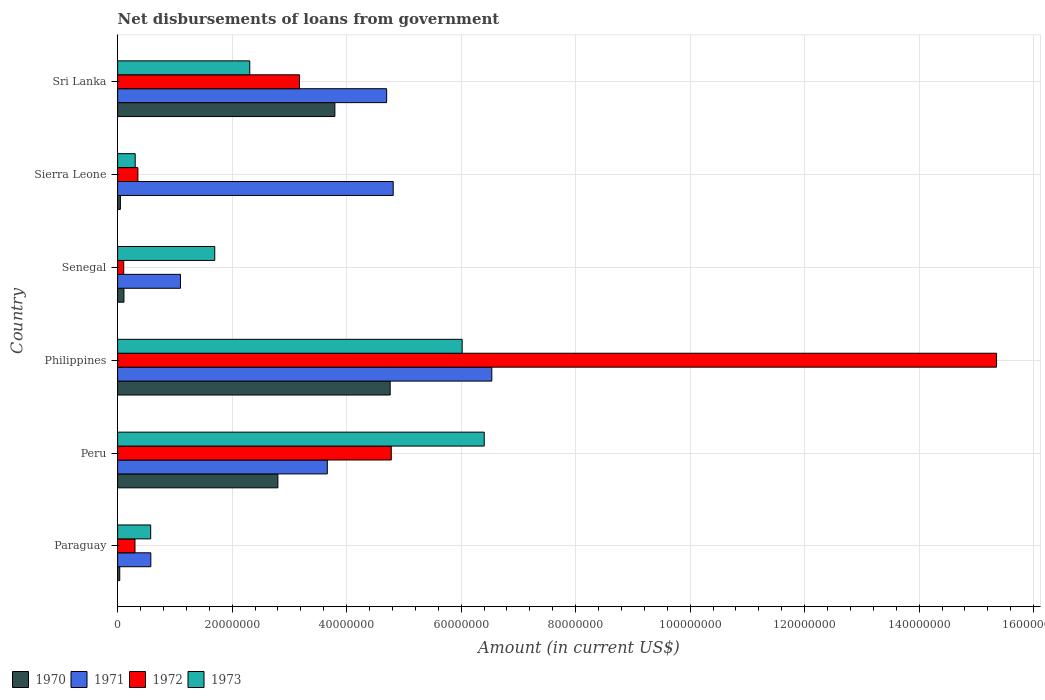How many different coloured bars are there?
Provide a short and direct response. 4. Are the number of bars per tick equal to the number of legend labels?
Your answer should be compact. Yes. Are the number of bars on each tick of the Y-axis equal?
Your response must be concise. Yes. How many bars are there on the 3rd tick from the top?
Provide a succinct answer. 4. How many bars are there on the 5th tick from the bottom?
Keep it short and to the point. 4. What is the amount of loan disbursed from government in 1972 in Paraguay?
Your answer should be compact. 3.04e+06. Across all countries, what is the maximum amount of loan disbursed from government in 1972?
Provide a short and direct response. 1.54e+08. Across all countries, what is the minimum amount of loan disbursed from government in 1971?
Offer a very short reply. 5.80e+06. In which country was the amount of loan disbursed from government in 1972 minimum?
Offer a terse response. Senegal. What is the total amount of loan disbursed from government in 1972 in the graph?
Provide a short and direct response. 2.41e+08. What is the difference between the amount of loan disbursed from government in 1973 in Peru and that in Senegal?
Make the answer very short. 4.71e+07. What is the difference between the amount of loan disbursed from government in 1970 in Philippines and the amount of loan disbursed from government in 1971 in Peru?
Give a very brief answer. 1.10e+07. What is the average amount of loan disbursed from government in 1970 per country?
Offer a terse response. 1.93e+07. What is the difference between the amount of loan disbursed from government in 1973 and amount of loan disbursed from government in 1970 in Peru?
Your answer should be compact. 3.60e+07. In how many countries, is the amount of loan disbursed from government in 1971 greater than 144000000 US$?
Your answer should be compact. 0. What is the ratio of the amount of loan disbursed from government in 1972 in Paraguay to that in Philippines?
Offer a very short reply. 0.02. Is the difference between the amount of loan disbursed from government in 1973 in Paraguay and Sierra Leone greater than the difference between the amount of loan disbursed from government in 1970 in Paraguay and Sierra Leone?
Offer a very short reply. Yes. What is the difference between the highest and the second highest amount of loan disbursed from government in 1971?
Provide a short and direct response. 1.72e+07. What is the difference between the highest and the lowest amount of loan disbursed from government in 1973?
Offer a very short reply. 6.10e+07. In how many countries, is the amount of loan disbursed from government in 1970 greater than the average amount of loan disbursed from government in 1970 taken over all countries?
Give a very brief answer. 3. Is it the case that in every country, the sum of the amount of loan disbursed from government in 1973 and amount of loan disbursed from government in 1971 is greater than the sum of amount of loan disbursed from government in 1970 and amount of loan disbursed from government in 1972?
Your answer should be very brief. Yes. Are the values on the major ticks of X-axis written in scientific E-notation?
Offer a terse response. No. Does the graph contain grids?
Offer a very short reply. Yes. How are the legend labels stacked?
Offer a very short reply. Horizontal. What is the title of the graph?
Provide a short and direct response. Net disbursements of loans from government. What is the Amount (in current US$) in 1970 in Paraguay?
Ensure brevity in your answer.  3.74e+05. What is the Amount (in current US$) in 1971 in Paraguay?
Keep it short and to the point. 5.80e+06. What is the Amount (in current US$) of 1972 in Paraguay?
Your answer should be compact. 3.04e+06. What is the Amount (in current US$) of 1973 in Paraguay?
Make the answer very short. 5.78e+06. What is the Amount (in current US$) of 1970 in Peru?
Your response must be concise. 2.80e+07. What is the Amount (in current US$) in 1971 in Peru?
Make the answer very short. 3.66e+07. What is the Amount (in current US$) of 1972 in Peru?
Your answer should be very brief. 4.78e+07. What is the Amount (in current US$) in 1973 in Peru?
Provide a succinct answer. 6.40e+07. What is the Amount (in current US$) in 1970 in Philippines?
Ensure brevity in your answer.  4.76e+07. What is the Amount (in current US$) of 1971 in Philippines?
Offer a terse response. 6.54e+07. What is the Amount (in current US$) of 1972 in Philippines?
Provide a succinct answer. 1.54e+08. What is the Amount (in current US$) of 1973 in Philippines?
Your answer should be compact. 6.02e+07. What is the Amount (in current US$) of 1970 in Senegal?
Make the answer very short. 1.11e+06. What is the Amount (in current US$) of 1971 in Senegal?
Your answer should be compact. 1.10e+07. What is the Amount (in current US$) of 1972 in Senegal?
Your answer should be compact. 1.07e+06. What is the Amount (in current US$) in 1973 in Senegal?
Offer a very short reply. 1.70e+07. What is the Amount (in current US$) in 1970 in Sierra Leone?
Offer a terse response. 4.87e+05. What is the Amount (in current US$) of 1971 in Sierra Leone?
Ensure brevity in your answer.  4.81e+07. What is the Amount (in current US$) of 1972 in Sierra Leone?
Your answer should be very brief. 3.54e+06. What is the Amount (in current US$) of 1973 in Sierra Leone?
Make the answer very short. 3.07e+06. What is the Amount (in current US$) in 1970 in Sri Lanka?
Provide a short and direct response. 3.79e+07. What is the Amount (in current US$) in 1971 in Sri Lanka?
Give a very brief answer. 4.70e+07. What is the Amount (in current US$) of 1972 in Sri Lanka?
Your answer should be very brief. 3.18e+07. What is the Amount (in current US$) in 1973 in Sri Lanka?
Your answer should be very brief. 2.31e+07. Across all countries, what is the maximum Amount (in current US$) in 1970?
Make the answer very short. 4.76e+07. Across all countries, what is the maximum Amount (in current US$) of 1971?
Offer a terse response. 6.54e+07. Across all countries, what is the maximum Amount (in current US$) of 1972?
Offer a terse response. 1.54e+08. Across all countries, what is the maximum Amount (in current US$) of 1973?
Ensure brevity in your answer.  6.40e+07. Across all countries, what is the minimum Amount (in current US$) of 1970?
Provide a short and direct response. 3.74e+05. Across all countries, what is the minimum Amount (in current US$) in 1971?
Your response must be concise. 5.80e+06. Across all countries, what is the minimum Amount (in current US$) of 1972?
Your response must be concise. 1.07e+06. Across all countries, what is the minimum Amount (in current US$) in 1973?
Offer a very short reply. 3.07e+06. What is the total Amount (in current US$) in 1970 in the graph?
Offer a terse response. 1.16e+08. What is the total Amount (in current US$) of 1971 in the graph?
Give a very brief answer. 2.14e+08. What is the total Amount (in current US$) in 1972 in the graph?
Your answer should be very brief. 2.41e+08. What is the total Amount (in current US$) in 1973 in the graph?
Offer a terse response. 1.73e+08. What is the difference between the Amount (in current US$) in 1970 in Paraguay and that in Peru?
Offer a very short reply. -2.76e+07. What is the difference between the Amount (in current US$) in 1971 in Paraguay and that in Peru?
Give a very brief answer. -3.08e+07. What is the difference between the Amount (in current US$) of 1972 in Paraguay and that in Peru?
Offer a terse response. -4.48e+07. What is the difference between the Amount (in current US$) of 1973 in Paraguay and that in Peru?
Your answer should be compact. -5.83e+07. What is the difference between the Amount (in current US$) of 1970 in Paraguay and that in Philippines?
Give a very brief answer. -4.72e+07. What is the difference between the Amount (in current US$) in 1971 in Paraguay and that in Philippines?
Offer a very short reply. -5.96e+07. What is the difference between the Amount (in current US$) in 1972 in Paraguay and that in Philippines?
Provide a succinct answer. -1.50e+08. What is the difference between the Amount (in current US$) of 1973 in Paraguay and that in Philippines?
Your response must be concise. -5.44e+07. What is the difference between the Amount (in current US$) in 1970 in Paraguay and that in Senegal?
Your answer should be compact. -7.32e+05. What is the difference between the Amount (in current US$) of 1971 in Paraguay and that in Senegal?
Your response must be concise. -5.18e+06. What is the difference between the Amount (in current US$) of 1972 in Paraguay and that in Senegal?
Provide a succinct answer. 1.97e+06. What is the difference between the Amount (in current US$) of 1973 in Paraguay and that in Senegal?
Provide a short and direct response. -1.12e+07. What is the difference between the Amount (in current US$) in 1970 in Paraguay and that in Sierra Leone?
Your answer should be very brief. -1.13e+05. What is the difference between the Amount (in current US$) of 1971 in Paraguay and that in Sierra Leone?
Ensure brevity in your answer.  -4.23e+07. What is the difference between the Amount (in current US$) in 1972 in Paraguay and that in Sierra Leone?
Provide a short and direct response. -5.07e+05. What is the difference between the Amount (in current US$) in 1973 in Paraguay and that in Sierra Leone?
Ensure brevity in your answer.  2.70e+06. What is the difference between the Amount (in current US$) of 1970 in Paraguay and that in Sri Lanka?
Offer a terse response. -3.76e+07. What is the difference between the Amount (in current US$) of 1971 in Paraguay and that in Sri Lanka?
Provide a short and direct response. -4.12e+07. What is the difference between the Amount (in current US$) in 1972 in Paraguay and that in Sri Lanka?
Provide a succinct answer. -2.87e+07. What is the difference between the Amount (in current US$) in 1973 in Paraguay and that in Sri Lanka?
Offer a very short reply. -1.73e+07. What is the difference between the Amount (in current US$) in 1970 in Peru and that in Philippines?
Offer a very short reply. -1.96e+07. What is the difference between the Amount (in current US$) in 1971 in Peru and that in Philippines?
Give a very brief answer. -2.87e+07. What is the difference between the Amount (in current US$) in 1972 in Peru and that in Philippines?
Provide a succinct answer. -1.06e+08. What is the difference between the Amount (in current US$) of 1973 in Peru and that in Philippines?
Provide a short and direct response. 3.86e+06. What is the difference between the Amount (in current US$) of 1970 in Peru and that in Senegal?
Your answer should be compact. 2.69e+07. What is the difference between the Amount (in current US$) of 1971 in Peru and that in Senegal?
Keep it short and to the point. 2.56e+07. What is the difference between the Amount (in current US$) in 1972 in Peru and that in Senegal?
Provide a succinct answer. 4.67e+07. What is the difference between the Amount (in current US$) of 1973 in Peru and that in Senegal?
Your answer should be compact. 4.71e+07. What is the difference between the Amount (in current US$) in 1970 in Peru and that in Sierra Leone?
Give a very brief answer. 2.75e+07. What is the difference between the Amount (in current US$) in 1971 in Peru and that in Sierra Leone?
Your answer should be very brief. -1.15e+07. What is the difference between the Amount (in current US$) of 1972 in Peru and that in Sierra Leone?
Your response must be concise. 4.43e+07. What is the difference between the Amount (in current US$) of 1973 in Peru and that in Sierra Leone?
Provide a short and direct response. 6.10e+07. What is the difference between the Amount (in current US$) of 1970 in Peru and that in Sri Lanka?
Your answer should be very brief. -9.95e+06. What is the difference between the Amount (in current US$) in 1971 in Peru and that in Sri Lanka?
Your answer should be compact. -1.04e+07. What is the difference between the Amount (in current US$) of 1972 in Peru and that in Sri Lanka?
Provide a succinct answer. 1.60e+07. What is the difference between the Amount (in current US$) in 1973 in Peru and that in Sri Lanka?
Provide a succinct answer. 4.10e+07. What is the difference between the Amount (in current US$) in 1970 in Philippines and that in Senegal?
Your response must be concise. 4.65e+07. What is the difference between the Amount (in current US$) of 1971 in Philippines and that in Senegal?
Offer a very short reply. 5.44e+07. What is the difference between the Amount (in current US$) in 1972 in Philippines and that in Senegal?
Your answer should be compact. 1.52e+08. What is the difference between the Amount (in current US$) in 1973 in Philippines and that in Senegal?
Your answer should be compact. 4.32e+07. What is the difference between the Amount (in current US$) in 1970 in Philippines and that in Sierra Leone?
Offer a very short reply. 4.71e+07. What is the difference between the Amount (in current US$) in 1971 in Philippines and that in Sierra Leone?
Offer a terse response. 1.72e+07. What is the difference between the Amount (in current US$) of 1972 in Philippines and that in Sierra Leone?
Provide a succinct answer. 1.50e+08. What is the difference between the Amount (in current US$) in 1973 in Philippines and that in Sierra Leone?
Provide a short and direct response. 5.71e+07. What is the difference between the Amount (in current US$) of 1970 in Philippines and that in Sri Lanka?
Make the answer very short. 9.66e+06. What is the difference between the Amount (in current US$) of 1971 in Philippines and that in Sri Lanka?
Provide a short and direct response. 1.84e+07. What is the difference between the Amount (in current US$) of 1972 in Philippines and that in Sri Lanka?
Offer a terse response. 1.22e+08. What is the difference between the Amount (in current US$) of 1973 in Philippines and that in Sri Lanka?
Offer a terse response. 3.71e+07. What is the difference between the Amount (in current US$) of 1970 in Senegal and that in Sierra Leone?
Your answer should be compact. 6.19e+05. What is the difference between the Amount (in current US$) of 1971 in Senegal and that in Sierra Leone?
Make the answer very short. -3.72e+07. What is the difference between the Amount (in current US$) of 1972 in Senegal and that in Sierra Leone?
Ensure brevity in your answer.  -2.48e+06. What is the difference between the Amount (in current US$) in 1973 in Senegal and that in Sierra Leone?
Your answer should be compact. 1.39e+07. What is the difference between the Amount (in current US$) of 1970 in Senegal and that in Sri Lanka?
Make the answer very short. -3.68e+07. What is the difference between the Amount (in current US$) in 1971 in Senegal and that in Sri Lanka?
Offer a very short reply. -3.60e+07. What is the difference between the Amount (in current US$) in 1972 in Senegal and that in Sri Lanka?
Your response must be concise. -3.07e+07. What is the difference between the Amount (in current US$) of 1973 in Senegal and that in Sri Lanka?
Provide a short and direct response. -6.12e+06. What is the difference between the Amount (in current US$) in 1970 in Sierra Leone and that in Sri Lanka?
Provide a succinct answer. -3.75e+07. What is the difference between the Amount (in current US$) of 1971 in Sierra Leone and that in Sri Lanka?
Offer a very short reply. 1.15e+06. What is the difference between the Amount (in current US$) of 1972 in Sierra Leone and that in Sri Lanka?
Give a very brief answer. -2.82e+07. What is the difference between the Amount (in current US$) in 1973 in Sierra Leone and that in Sri Lanka?
Provide a short and direct response. -2.00e+07. What is the difference between the Amount (in current US$) of 1970 in Paraguay and the Amount (in current US$) of 1971 in Peru?
Offer a terse response. -3.63e+07. What is the difference between the Amount (in current US$) of 1970 in Paraguay and the Amount (in current US$) of 1972 in Peru?
Keep it short and to the point. -4.74e+07. What is the difference between the Amount (in current US$) of 1970 in Paraguay and the Amount (in current US$) of 1973 in Peru?
Provide a short and direct response. -6.37e+07. What is the difference between the Amount (in current US$) in 1971 in Paraguay and the Amount (in current US$) in 1972 in Peru?
Your response must be concise. -4.20e+07. What is the difference between the Amount (in current US$) in 1971 in Paraguay and the Amount (in current US$) in 1973 in Peru?
Your answer should be very brief. -5.82e+07. What is the difference between the Amount (in current US$) in 1972 in Paraguay and the Amount (in current US$) in 1973 in Peru?
Your response must be concise. -6.10e+07. What is the difference between the Amount (in current US$) of 1970 in Paraguay and the Amount (in current US$) of 1971 in Philippines?
Your answer should be compact. -6.50e+07. What is the difference between the Amount (in current US$) in 1970 in Paraguay and the Amount (in current US$) in 1972 in Philippines?
Keep it short and to the point. -1.53e+08. What is the difference between the Amount (in current US$) in 1970 in Paraguay and the Amount (in current US$) in 1973 in Philippines?
Provide a succinct answer. -5.98e+07. What is the difference between the Amount (in current US$) in 1971 in Paraguay and the Amount (in current US$) in 1972 in Philippines?
Offer a terse response. -1.48e+08. What is the difference between the Amount (in current US$) in 1971 in Paraguay and the Amount (in current US$) in 1973 in Philippines?
Keep it short and to the point. -5.44e+07. What is the difference between the Amount (in current US$) in 1972 in Paraguay and the Amount (in current US$) in 1973 in Philippines?
Your answer should be compact. -5.71e+07. What is the difference between the Amount (in current US$) in 1970 in Paraguay and the Amount (in current US$) in 1971 in Senegal?
Give a very brief answer. -1.06e+07. What is the difference between the Amount (in current US$) in 1970 in Paraguay and the Amount (in current US$) in 1972 in Senegal?
Offer a terse response. -6.92e+05. What is the difference between the Amount (in current US$) in 1970 in Paraguay and the Amount (in current US$) in 1973 in Senegal?
Keep it short and to the point. -1.66e+07. What is the difference between the Amount (in current US$) in 1971 in Paraguay and the Amount (in current US$) in 1972 in Senegal?
Offer a very short reply. 4.74e+06. What is the difference between the Amount (in current US$) in 1971 in Paraguay and the Amount (in current US$) in 1973 in Senegal?
Give a very brief answer. -1.12e+07. What is the difference between the Amount (in current US$) in 1972 in Paraguay and the Amount (in current US$) in 1973 in Senegal?
Offer a terse response. -1.39e+07. What is the difference between the Amount (in current US$) in 1970 in Paraguay and the Amount (in current US$) in 1971 in Sierra Leone?
Provide a short and direct response. -4.78e+07. What is the difference between the Amount (in current US$) in 1970 in Paraguay and the Amount (in current US$) in 1972 in Sierra Leone?
Provide a short and direct response. -3.17e+06. What is the difference between the Amount (in current US$) in 1970 in Paraguay and the Amount (in current US$) in 1973 in Sierra Leone?
Keep it short and to the point. -2.70e+06. What is the difference between the Amount (in current US$) in 1971 in Paraguay and the Amount (in current US$) in 1972 in Sierra Leone?
Provide a short and direct response. 2.26e+06. What is the difference between the Amount (in current US$) in 1971 in Paraguay and the Amount (in current US$) in 1973 in Sierra Leone?
Keep it short and to the point. 2.73e+06. What is the difference between the Amount (in current US$) of 1972 in Paraguay and the Amount (in current US$) of 1973 in Sierra Leone?
Your response must be concise. -3.80e+04. What is the difference between the Amount (in current US$) in 1970 in Paraguay and the Amount (in current US$) in 1971 in Sri Lanka?
Your answer should be compact. -4.66e+07. What is the difference between the Amount (in current US$) of 1970 in Paraguay and the Amount (in current US$) of 1972 in Sri Lanka?
Offer a terse response. -3.14e+07. What is the difference between the Amount (in current US$) of 1970 in Paraguay and the Amount (in current US$) of 1973 in Sri Lanka?
Provide a short and direct response. -2.27e+07. What is the difference between the Amount (in current US$) of 1971 in Paraguay and the Amount (in current US$) of 1972 in Sri Lanka?
Keep it short and to the point. -2.60e+07. What is the difference between the Amount (in current US$) in 1971 in Paraguay and the Amount (in current US$) in 1973 in Sri Lanka?
Make the answer very short. -1.73e+07. What is the difference between the Amount (in current US$) in 1972 in Paraguay and the Amount (in current US$) in 1973 in Sri Lanka?
Ensure brevity in your answer.  -2.00e+07. What is the difference between the Amount (in current US$) of 1970 in Peru and the Amount (in current US$) of 1971 in Philippines?
Your answer should be compact. -3.74e+07. What is the difference between the Amount (in current US$) of 1970 in Peru and the Amount (in current US$) of 1972 in Philippines?
Offer a very short reply. -1.26e+08. What is the difference between the Amount (in current US$) of 1970 in Peru and the Amount (in current US$) of 1973 in Philippines?
Your response must be concise. -3.22e+07. What is the difference between the Amount (in current US$) in 1971 in Peru and the Amount (in current US$) in 1972 in Philippines?
Ensure brevity in your answer.  -1.17e+08. What is the difference between the Amount (in current US$) in 1971 in Peru and the Amount (in current US$) in 1973 in Philippines?
Your answer should be compact. -2.36e+07. What is the difference between the Amount (in current US$) of 1972 in Peru and the Amount (in current US$) of 1973 in Philippines?
Make the answer very short. -1.24e+07. What is the difference between the Amount (in current US$) in 1970 in Peru and the Amount (in current US$) in 1971 in Senegal?
Keep it short and to the point. 1.70e+07. What is the difference between the Amount (in current US$) of 1970 in Peru and the Amount (in current US$) of 1972 in Senegal?
Offer a very short reply. 2.69e+07. What is the difference between the Amount (in current US$) of 1970 in Peru and the Amount (in current US$) of 1973 in Senegal?
Make the answer very short. 1.10e+07. What is the difference between the Amount (in current US$) of 1971 in Peru and the Amount (in current US$) of 1972 in Senegal?
Keep it short and to the point. 3.56e+07. What is the difference between the Amount (in current US$) of 1971 in Peru and the Amount (in current US$) of 1973 in Senegal?
Provide a succinct answer. 1.97e+07. What is the difference between the Amount (in current US$) in 1972 in Peru and the Amount (in current US$) in 1973 in Senegal?
Give a very brief answer. 3.08e+07. What is the difference between the Amount (in current US$) of 1970 in Peru and the Amount (in current US$) of 1971 in Sierra Leone?
Provide a succinct answer. -2.01e+07. What is the difference between the Amount (in current US$) of 1970 in Peru and the Amount (in current US$) of 1972 in Sierra Leone?
Provide a succinct answer. 2.45e+07. What is the difference between the Amount (in current US$) of 1970 in Peru and the Amount (in current US$) of 1973 in Sierra Leone?
Offer a terse response. 2.49e+07. What is the difference between the Amount (in current US$) in 1971 in Peru and the Amount (in current US$) in 1972 in Sierra Leone?
Your response must be concise. 3.31e+07. What is the difference between the Amount (in current US$) of 1971 in Peru and the Amount (in current US$) of 1973 in Sierra Leone?
Make the answer very short. 3.36e+07. What is the difference between the Amount (in current US$) of 1972 in Peru and the Amount (in current US$) of 1973 in Sierra Leone?
Give a very brief answer. 4.47e+07. What is the difference between the Amount (in current US$) of 1970 in Peru and the Amount (in current US$) of 1971 in Sri Lanka?
Ensure brevity in your answer.  -1.90e+07. What is the difference between the Amount (in current US$) in 1970 in Peru and the Amount (in current US$) in 1972 in Sri Lanka?
Provide a short and direct response. -3.77e+06. What is the difference between the Amount (in current US$) of 1970 in Peru and the Amount (in current US$) of 1973 in Sri Lanka?
Keep it short and to the point. 4.91e+06. What is the difference between the Amount (in current US$) in 1971 in Peru and the Amount (in current US$) in 1972 in Sri Lanka?
Offer a very short reply. 4.86e+06. What is the difference between the Amount (in current US$) in 1971 in Peru and the Amount (in current US$) in 1973 in Sri Lanka?
Your response must be concise. 1.35e+07. What is the difference between the Amount (in current US$) of 1972 in Peru and the Amount (in current US$) of 1973 in Sri Lanka?
Provide a succinct answer. 2.47e+07. What is the difference between the Amount (in current US$) of 1970 in Philippines and the Amount (in current US$) of 1971 in Senegal?
Your answer should be very brief. 3.66e+07. What is the difference between the Amount (in current US$) of 1970 in Philippines and the Amount (in current US$) of 1972 in Senegal?
Ensure brevity in your answer.  4.65e+07. What is the difference between the Amount (in current US$) of 1970 in Philippines and the Amount (in current US$) of 1973 in Senegal?
Make the answer very short. 3.06e+07. What is the difference between the Amount (in current US$) in 1971 in Philippines and the Amount (in current US$) in 1972 in Senegal?
Ensure brevity in your answer.  6.43e+07. What is the difference between the Amount (in current US$) of 1971 in Philippines and the Amount (in current US$) of 1973 in Senegal?
Provide a succinct answer. 4.84e+07. What is the difference between the Amount (in current US$) of 1972 in Philippines and the Amount (in current US$) of 1973 in Senegal?
Offer a terse response. 1.37e+08. What is the difference between the Amount (in current US$) in 1970 in Philippines and the Amount (in current US$) in 1971 in Sierra Leone?
Your response must be concise. -5.32e+05. What is the difference between the Amount (in current US$) of 1970 in Philippines and the Amount (in current US$) of 1972 in Sierra Leone?
Make the answer very short. 4.41e+07. What is the difference between the Amount (in current US$) of 1970 in Philippines and the Amount (in current US$) of 1973 in Sierra Leone?
Your answer should be very brief. 4.45e+07. What is the difference between the Amount (in current US$) in 1971 in Philippines and the Amount (in current US$) in 1972 in Sierra Leone?
Keep it short and to the point. 6.18e+07. What is the difference between the Amount (in current US$) in 1971 in Philippines and the Amount (in current US$) in 1973 in Sierra Leone?
Provide a short and direct response. 6.23e+07. What is the difference between the Amount (in current US$) of 1972 in Philippines and the Amount (in current US$) of 1973 in Sierra Leone?
Your answer should be compact. 1.50e+08. What is the difference between the Amount (in current US$) of 1970 in Philippines and the Amount (in current US$) of 1971 in Sri Lanka?
Make the answer very short. 6.15e+05. What is the difference between the Amount (in current US$) in 1970 in Philippines and the Amount (in current US$) in 1972 in Sri Lanka?
Ensure brevity in your answer.  1.58e+07. What is the difference between the Amount (in current US$) of 1970 in Philippines and the Amount (in current US$) of 1973 in Sri Lanka?
Give a very brief answer. 2.45e+07. What is the difference between the Amount (in current US$) of 1971 in Philippines and the Amount (in current US$) of 1972 in Sri Lanka?
Give a very brief answer. 3.36e+07. What is the difference between the Amount (in current US$) in 1971 in Philippines and the Amount (in current US$) in 1973 in Sri Lanka?
Provide a short and direct response. 4.23e+07. What is the difference between the Amount (in current US$) of 1972 in Philippines and the Amount (in current US$) of 1973 in Sri Lanka?
Provide a short and direct response. 1.30e+08. What is the difference between the Amount (in current US$) of 1970 in Senegal and the Amount (in current US$) of 1971 in Sierra Leone?
Provide a short and direct response. -4.70e+07. What is the difference between the Amount (in current US$) of 1970 in Senegal and the Amount (in current US$) of 1972 in Sierra Leone?
Your response must be concise. -2.44e+06. What is the difference between the Amount (in current US$) in 1970 in Senegal and the Amount (in current US$) in 1973 in Sierra Leone?
Keep it short and to the point. -1.97e+06. What is the difference between the Amount (in current US$) of 1971 in Senegal and the Amount (in current US$) of 1972 in Sierra Leone?
Provide a short and direct response. 7.44e+06. What is the difference between the Amount (in current US$) of 1971 in Senegal and the Amount (in current US$) of 1973 in Sierra Leone?
Offer a very short reply. 7.90e+06. What is the difference between the Amount (in current US$) in 1972 in Senegal and the Amount (in current US$) in 1973 in Sierra Leone?
Your answer should be very brief. -2.01e+06. What is the difference between the Amount (in current US$) in 1970 in Senegal and the Amount (in current US$) in 1971 in Sri Lanka?
Make the answer very short. -4.59e+07. What is the difference between the Amount (in current US$) in 1970 in Senegal and the Amount (in current US$) in 1972 in Sri Lanka?
Offer a terse response. -3.07e+07. What is the difference between the Amount (in current US$) of 1970 in Senegal and the Amount (in current US$) of 1973 in Sri Lanka?
Offer a terse response. -2.20e+07. What is the difference between the Amount (in current US$) in 1971 in Senegal and the Amount (in current US$) in 1972 in Sri Lanka?
Give a very brief answer. -2.08e+07. What is the difference between the Amount (in current US$) in 1971 in Senegal and the Amount (in current US$) in 1973 in Sri Lanka?
Provide a succinct answer. -1.21e+07. What is the difference between the Amount (in current US$) of 1972 in Senegal and the Amount (in current US$) of 1973 in Sri Lanka?
Give a very brief answer. -2.20e+07. What is the difference between the Amount (in current US$) of 1970 in Sierra Leone and the Amount (in current US$) of 1971 in Sri Lanka?
Your answer should be compact. -4.65e+07. What is the difference between the Amount (in current US$) of 1970 in Sierra Leone and the Amount (in current US$) of 1972 in Sri Lanka?
Offer a very short reply. -3.13e+07. What is the difference between the Amount (in current US$) of 1970 in Sierra Leone and the Amount (in current US$) of 1973 in Sri Lanka?
Offer a terse response. -2.26e+07. What is the difference between the Amount (in current US$) of 1971 in Sierra Leone and the Amount (in current US$) of 1972 in Sri Lanka?
Give a very brief answer. 1.64e+07. What is the difference between the Amount (in current US$) in 1971 in Sierra Leone and the Amount (in current US$) in 1973 in Sri Lanka?
Ensure brevity in your answer.  2.51e+07. What is the difference between the Amount (in current US$) in 1972 in Sierra Leone and the Amount (in current US$) in 1973 in Sri Lanka?
Your response must be concise. -1.95e+07. What is the average Amount (in current US$) of 1970 per country?
Offer a very short reply. 1.93e+07. What is the average Amount (in current US$) in 1971 per country?
Keep it short and to the point. 3.56e+07. What is the average Amount (in current US$) of 1972 per country?
Provide a succinct answer. 4.01e+07. What is the average Amount (in current US$) of 1973 per country?
Provide a short and direct response. 2.89e+07. What is the difference between the Amount (in current US$) of 1970 and Amount (in current US$) of 1971 in Paraguay?
Your response must be concise. -5.43e+06. What is the difference between the Amount (in current US$) of 1970 and Amount (in current US$) of 1972 in Paraguay?
Keep it short and to the point. -2.66e+06. What is the difference between the Amount (in current US$) in 1970 and Amount (in current US$) in 1973 in Paraguay?
Your response must be concise. -5.40e+06. What is the difference between the Amount (in current US$) of 1971 and Amount (in current US$) of 1972 in Paraguay?
Keep it short and to the point. 2.77e+06. What is the difference between the Amount (in current US$) in 1971 and Amount (in current US$) in 1973 in Paraguay?
Provide a short and direct response. 2.50e+04. What is the difference between the Amount (in current US$) of 1972 and Amount (in current US$) of 1973 in Paraguay?
Offer a very short reply. -2.74e+06. What is the difference between the Amount (in current US$) of 1970 and Amount (in current US$) of 1971 in Peru?
Provide a short and direct response. -8.63e+06. What is the difference between the Amount (in current US$) in 1970 and Amount (in current US$) in 1972 in Peru?
Ensure brevity in your answer.  -1.98e+07. What is the difference between the Amount (in current US$) of 1970 and Amount (in current US$) of 1973 in Peru?
Your response must be concise. -3.60e+07. What is the difference between the Amount (in current US$) in 1971 and Amount (in current US$) in 1972 in Peru?
Your answer should be compact. -1.12e+07. What is the difference between the Amount (in current US$) in 1971 and Amount (in current US$) in 1973 in Peru?
Provide a short and direct response. -2.74e+07. What is the difference between the Amount (in current US$) in 1972 and Amount (in current US$) in 1973 in Peru?
Offer a very short reply. -1.62e+07. What is the difference between the Amount (in current US$) in 1970 and Amount (in current US$) in 1971 in Philippines?
Your answer should be very brief. -1.78e+07. What is the difference between the Amount (in current US$) of 1970 and Amount (in current US$) of 1972 in Philippines?
Your answer should be very brief. -1.06e+08. What is the difference between the Amount (in current US$) of 1970 and Amount (in current US$) of 1973 in Philippines?
Give a very brief answer. -1.26e+07. What is the difference between the Amount (in current US$) of 1971 and Amount (in current US$) of 1972 in Philippines?
Provide a succinct answer. -8.82e+07. What is the difference between the Amount (in current US$) in 1971 and Amount (in current US$) in 1973 in Philippines?
Offer a very short reply. 5.18e+06. What is the difference between the Amount (in current US$) of 1972 and Amount (in current US$) of 1973 in Philippines?
Give a very brief answer. 9.33e+07. What is the difference between the Amount (in current US$) of 1970 and Amount (in current US$) of 1971 in Senegal?
Offer a terse response. -9.87e+06. What is the difference between the Amount (in current US$) of 1970 and Amount (in current US$) of 1972 in Senegal?
Give a very brief answer. 4.00e+04. What is the difference between the Amount (in current US$) of 1970 and Amount (in current US$) of 1973 in Senegal?
Your response must be concise. -1.59e+07. What is the difference between the Amount (in current US$) in 1971 and Amount (in current US$) in 1972 in Senegal?
Make the answer very short. 9.91e+06. What is the difference between the Amount (in current US$) in 1971 and Amount (in current US$) in 1973 in Senegal?
Your answer should be compact. -5.99e+06. What is the difference between the Amount (in current US$) of 1972 and Amount (in current US$) of 1973 in Senegal?
Offer a very short reply. -1.59e+07. What is the difference between the Amount (in current US$) in 1970 and Amount (in current US$) in 1971 in Sierra Leone?
Provide a short and direct response. -4.77e+07. What is the difference between the Amount (in current US$) of 1970 and Amount (in current US$) of 1972 in Sierra Leone?
Offer a very short reply. -3.06e+06. What is the difference between the Amount (in current US$) of 1970 and Amount (in current US$) of 1973 in Sierra Leone?
Provide a short and direct response. -2.59e+06. What is the difference between the Amount (in current US$) of 1971 and Amount (in current US$) of 1972 in Sierra Leone?
Provide a short and direct response. 4.46e+07. What is the difference between the Amount (in current US$) of 1971 and Amount (in current US$) of 1973 in Sierra Leone?
Provide a succinct answer. 4.51e+07. What is the difference between the Amount (in current US$) in 1972 and Amount (in current US$) in 1973 in Sierra Leone?
Provide a short and direct response. 4.69e+05. What is the difference between the Amount (in current US$) of 1970 and Amount (in current US$) of 1971 in Sri Lanka?
Your answer should be compact. -9.04e+06. What is the difference between the Amount (in current US$) in 1970 and Amount (in current US$) in 1972 in Sri Lanka?
Keep it short and to the point. 6.18e+06. What is the difference between the Amount (in current US$) in 1970 and Amount (in current US$) in 1973 in Sri Lanka?
Provide a succinct answer. 1.49e+07. What is the difference between the Amount (in current US$) in 1971 and Amount (in current US$) in 1972 in Sri Lanka?
Your answer should be very brief. 1.52e+07. What is the difference between the Amount (in current US$) of 1971 and Amount (in current US$) of 1973 in Sri Lanka?
Your answer should be compact. 2.39e+07. What is the difference between the Amount (in current US$) in 1972 and Amount (in current US$) in 1973 in Sri Lanka?
Provide a succinct answer. 8.69e+06. What is the ratio of the Amount (in current US$) of 1970 in Paraguay to that in Peru?
Provide a succinct answer. 0.01. What is the ratio of the Amount (in current US$) in 1971 in Paraguay to that in Peru?
Make the answer very short. 0.16. What is the ratio of the Amount (in current US$) of 1972 in Paraguay to that in Peru?
Your response must be concise. 0.06. What is the ratio of the Amount (in current US$) in 1973 in Paraguay to that in Peru?
Make the answer very short. 0.09. What is the ratio of the Amount (in current US$) of 1970 in Paraguay to that in Philippines?
Provide a succinct answer. 0.01. What is the ratio of the Amount (in current US$) of 1971 in Paraguay to that in Philippines?
Your answer should be very brief. 0.09. What is the ratio of the Amount (in current US$) in 1972 in Paraguay to that in Philippines?
Give a very brief answer. 0.02. What is the ratio of the Amount (in current US$) in 1973 in Paraguay to that in Philippines?
Your answer should be compact. 0.1. What is the ratio of the Amount (in current US$) in 1970 in Paraguay to that in Senegal?
Offer a very short reply. 0.34. What is the ratio of the Amount (in current US$) in 1971 in Paraguay to that in Senegal?
Offer a terse response. 0.53. What is the ratio of the Amount (in current US$) in 1972 in Paraguay to that in Senegal?
Offer a very short reply. 2.85. What is the ratio of the Amount (in current US$) in 1973 in Paraguay to that in Senegal?
Provide a short and direct response. 0.34. What is the ratio of the Amount (in current US$) of 1970 in Paraguay to that in Sierra Leone?
Ensure brevity in your answer.  0.77. What is the ratio of the Amount (in current US$) of 1971 in Paraguay to that in Sierra Leone?
Your answer should be very brief. 0.12. What is the ratio of the Amount (in current US$) in 1972 in Paraguay to that in Sierra Leone?
Give a very brief answer. 0.86. What is the ratio of the Amount (in current US$) in 1973 in Paraguay to that in Sierra Leone?
Offer a terse response. 1.88. What is the ratio of the Amount (in current US$) of 1970 in Paraguay to that in Sri Lanka?
Offer a very short reply. 0.01. What is the ratio of the Amount (in current US$) in 1971 in Paraguay to that in Sri Lanka?
Your response must be concise. 0.12. What is the ratio of the Amount (in current US$) of 1972 in Paraguay to that in Sri Lanka?
Make the answer very short. 0.1. What is the ratio of the Amount (in current US$) in 1973 in Paraguay to that in Sri Lanka?
Make the answer very short. 0.25. What is the ratio of the Amount (in current US$) in 1970 in Peru to that in Philippines?
Your answer should be compact. 0.59. What is the ratio of the Amount (in current US$) in 1971 in Peru to that in Philippines?
Offer a very short reply. 0.56. What is the ratio of the Amount (in current US$) in 1972 in Peru to that in Philippines?
Your answer should be compact. 0.31. What is the ratio of the Amount (in current US$) in 1973 in Peru to that in Philippines?
Offer a very short reply. 1.06. What is the ratio of the Amount (in current US$) of 1970 in Peru to that in Senegal?
Your answer should be very brief. 25.31. What is the ratio of the Amount (in current US$) of 1971 in Peru to that in Senegal?
Make the answer very short. 3.34. What is the ratio of the Amount (in current US$) of 1972 in Peru to that in Senegal?
Your response must be concise. 44.84. What is the ratio of the Amount (in current US$) of 1973 in Peru to that in Senegal?
Provide a succinct answer. 3.77. What is the ratio of the Amount (in current US$) in 1970 in Peru to that in Sierra Leone?
Make the answer very short. 57.49. What is the ratio of the Amount (in current US$) of 1971 in Peru to that in Sierra Leone?
Give a very brief answer. 0.76. What is the ratio of the Amount (in current US$) in 1972 in Peru to that in Sierra Leone?
Provide a short and direct response. 13.49. What is the ratio of the Amount (in current US$) in 1973 in Peru to that in Sierra Leone?
Your answer should be compact. 20.83. What is the ratio of the Amount (in current US$) of 1970 in Peru to that in Sri Lanka?
Your answer should be very brief. 0.74. What is the ratio of the Amount (in current US$) of 1971 in Peru to that in Sri Lanka?
Your answer should be compact. 0.78. What is the ratio of the Amount (in current US$) in 1972 in Peru to that in Sri Lanka?
Your response must be concise. 1.5. What is the ratio of the Amount (in current US$) in 1973 in Peru to that in Sri Lanka?
Your answer should be very brief. 2.77. What is the ratio of the Amount (in current US$) in 1970 in Philippines to that in Senegal?
Make the answer very short. 43.04. What is the ratio of the Amount (in current US$) in 1971 in Philippines to that in Senegal?
Offer a very short reply. 5.95. What is the ratio of the Amount (in current US$) of 1972 in Philippines to that in Senegal?
Your answer should be very brief. 144.01. What is the ratio of the Amount (in current US$) in 1973 in Philippines to that in Senegal?
Ensure brevity in your answer.  3.55. What is the ratio of the Amount (in current US$) in 1970 in Philippines to that in Sierra Leone?
Make the answer very short. 97.75. What is the ratio of the Amount (in current US$) of 1971 in Philippines to that in Sierra Leone?
Provide a succinct answer. 1.36. What is the ratio of the Amount (in current US$) of 1972 in Philippines to that in Sierra Leone?
Give a very brief answer. 43.33. What is the ratio of the Amount (in current US$) in 1973 in Philippines to that in Sierra Leone?
Ensure brevity in your answer.  19.58. What is the ratio of the Amount (in current US$) of 1970 in Philippines to that in Sri Lanka?
Ensure brevity in your answer.  1.25. What is the ratio of the Amount (in current US$) of 1971 in Philippines to that in Sri Lanka?
Offer a terse response. 1.39. What is the ratio of the Amount (in current US$) in 1972 in Philippines to that in Sri Lanka?
Your response must be concise. 4.83. What is the ratio of the Amount (in current US$) in 1973 in Philippines to that in Sri Lanka?
Your response must be concise. 2.61. What is the ratio of the Amount (in current US$) in 1970 in Senegal to that in Sierra Leone?
Keep it short and to the point. 2.27. What is the ratio of the Amount (in current US$) of 1971 in Senegal to that in Sierra Leone?
Provide a succinct answer. 0.23. What is the ratio of the Amount (in current US$) of 1972 in Senegal to that in Sierra Leone?
Give a very brief answer. 0.3. What is the ratio of the Amount (in current US$) of 1973 in Senegal to that in Sierra Leone?
Your answer should be compact. 5.52. What is the ratio of the Amount (in current US$) of 1970 in Senegal to that in Sri Lanka?
Provide a short and direct response. 0.03. What is the ratio of the Amount (in current US$) of 1971 in Senegal to that in Sri Lanka?
Keep it short and to the point. 0.23. What is the ratio of the Amount (in current US$) of 1972 in Senegal to that in Sri Lanka?
Offer a terse response. 0.03. What is the ratio of the Amount (in current US$) in 1973 in Senegal to that in Sri Lanka?
Offer a terse response. 0.73. What is the ratio of the Amount (in current US$) in 1970 in Sierra Leone to that in Sri Lanka?
Keep it short and to the point. 0.01. What is the ratio of the Amount (in current US$) in 1971 in Sierra Leone to that in Sri Lanka?
Your answer should be very brief. 1.02. What is the ratio of the Amount (in current US$) in 1972 in Sierra Leone to that in Sri Lanka?
Your response must be concise. 0.11. What is the ratio of the Amount (in current US$) of 1973 in Sierra Leone to that in Sri Lanka?
Keep it short and to the point. 0.13. What is the difference between the highest and the second highest Amount (in current US$) in 1970?
Your answer should be very brief. 9.66e+06. What is the difference between the highest and the second highest Amount (in current US$) of 1971?
Your answer should be very brief. 1.72e+07. What is the difference between the highest and the second highest Amount (in current US$) in 1972?
Offer a terse response. 1.06e+08. What is the difference between the highest and the second highest Amount (in current US$) of 1973?
Keep it short and to the point. 3.86e+06. What is the difference between the highest and the lowest Amount (in current US$) of 1970?
Your response must be concise. 4.72e+07. What is the difference between the highest and the lowest Amount (in current US$) of 1971?
Your response must be concise. 5.96e+07. What is the difference between the highest and the lowest Amount (in current US$) of 1972?
Provide a succinct answer. 1.52e+08. What is the difference between the highest and the lowest Amount (in current US$) of 1973?
Keep it short and to the point. 6.10e+07. 